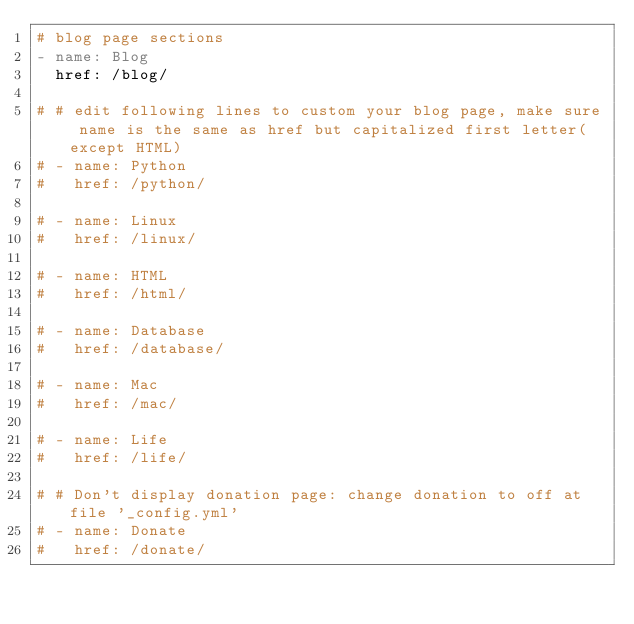Convert code to text. <code><loc_0><loc_0><loc_500><loc_500><_YAML_># blog page sections
- name: Blog
  href: /blog/

# # edit following lines to custom your blog page, make sure name is the same as href but capitalized first letter(except HTML)
# - name: Python
#   href: /python/

# - name: Linux
#   href: /linux/

# - name: HTML
#   href: /html/

# - name: Database
#   href: /database/

# - name: Mac
#   href: /mac/

# - name: Life
#   href: /life/

# # Don't display donation page: change donation to off at file '_config.yml'
# - name: Donate
#   href: /donate/
</code> 